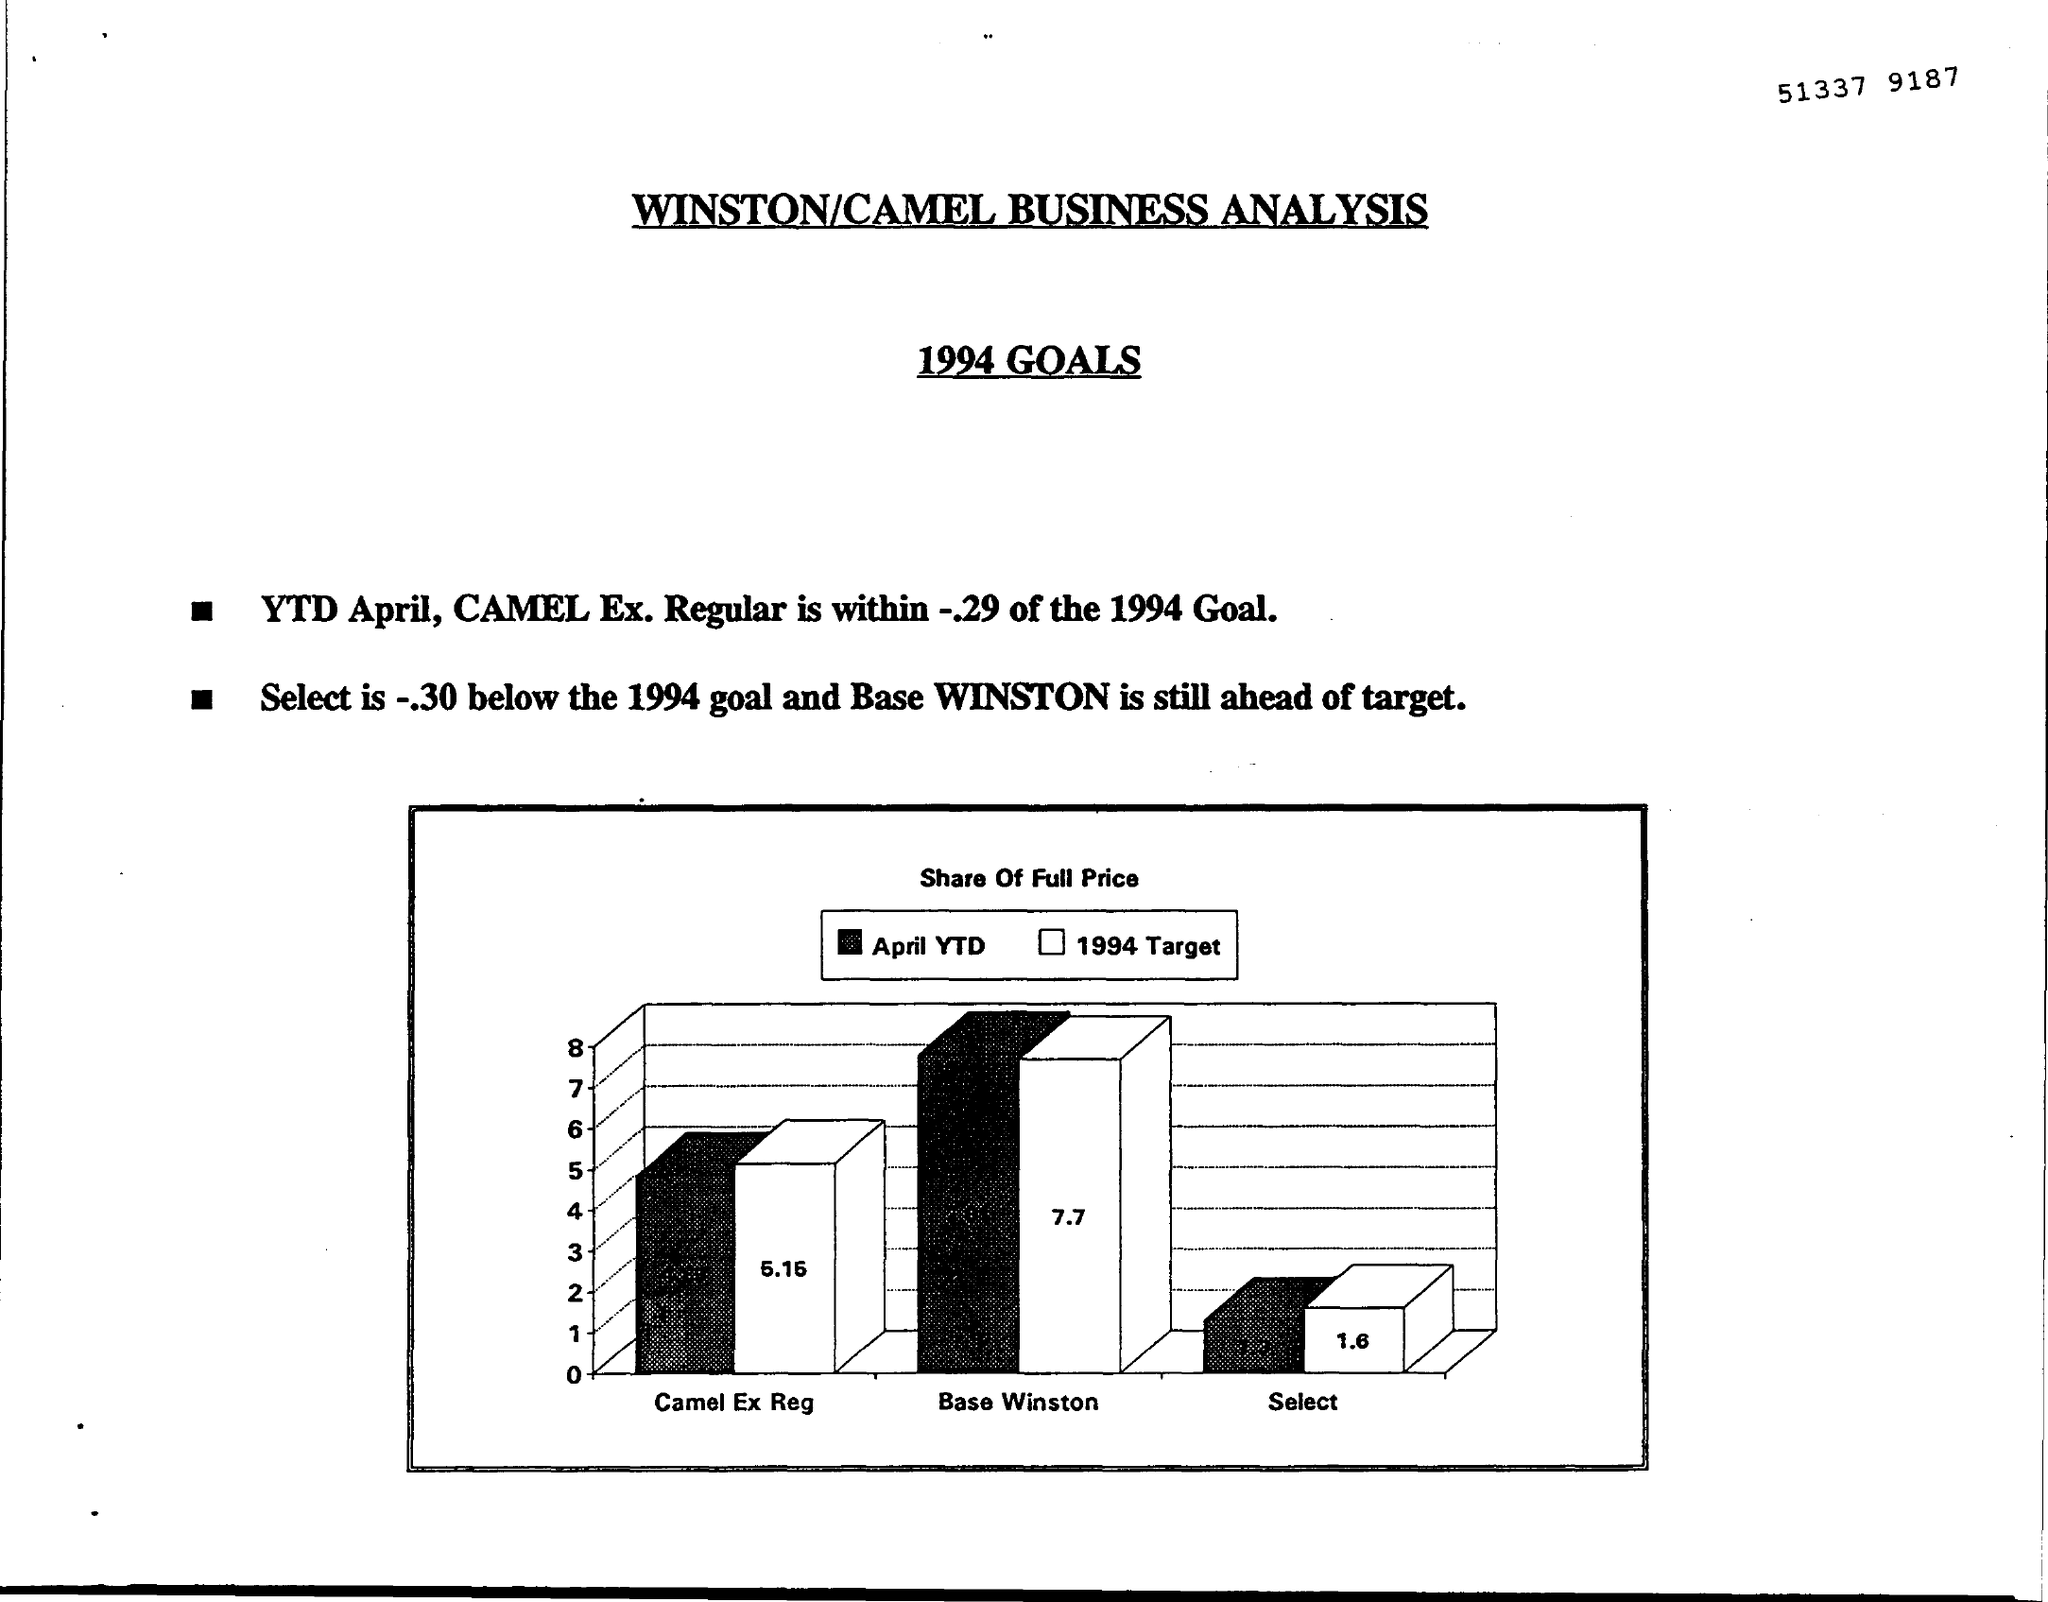Mention a couple of crucial points in this snapshot. The goals are valid for the year 1994. The document title is 'WINSTON/CAMEL BUSINESS ANALYSIS.' The white bar indicates that the target date is 1994. The title of the figure is [insert title], which represents the share of full-price sales in the market. [Insert additional details, if applicable] 